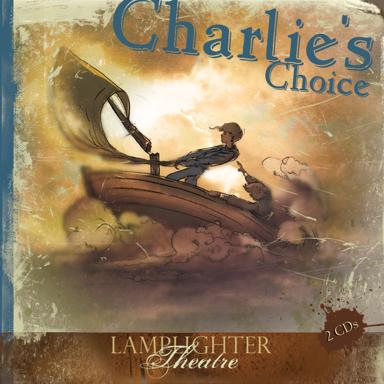What is the theme of 'Charlie's Choice' as depicted on the cover? The cover of 'Charlie's Choice' depicts a young boy steering a small sailing boat through cloud-like waves, suggesting themes of adventure, personal journey, and perhaps a coming-of-age story where the protagonist faces and overcomes challenges. 